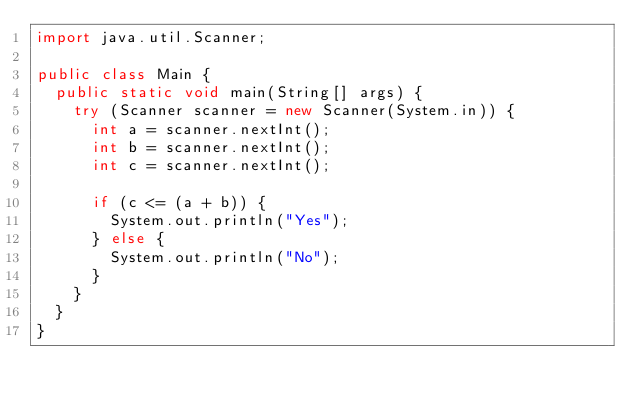<code> <loc_0><loc_0><loc_500><loc_500><_Java_>import java.util.Scanner;

public class Main {
	public static void main(String[] args) {
		try (Scanner scanner = new Scanner(System.in)) {
			int a = scanner.nextInt();
			int b = scanner.nextInt();
			int c = scanner.nextInt();

			if (c <= (a + b)) {
				System.out.println("Yes");
			} else {
				System.out.println("No");
			}
		}
	}
}
</code> 